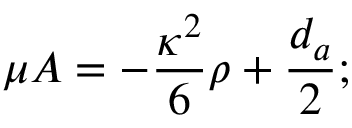<formula> <loc_0><loc_0><loc_500><loc_500>\mu A = - \frac { \kappa ^ { 2 } } { 6 } \rho + \frac { d _ { a } } { 2 } ;</formula> 